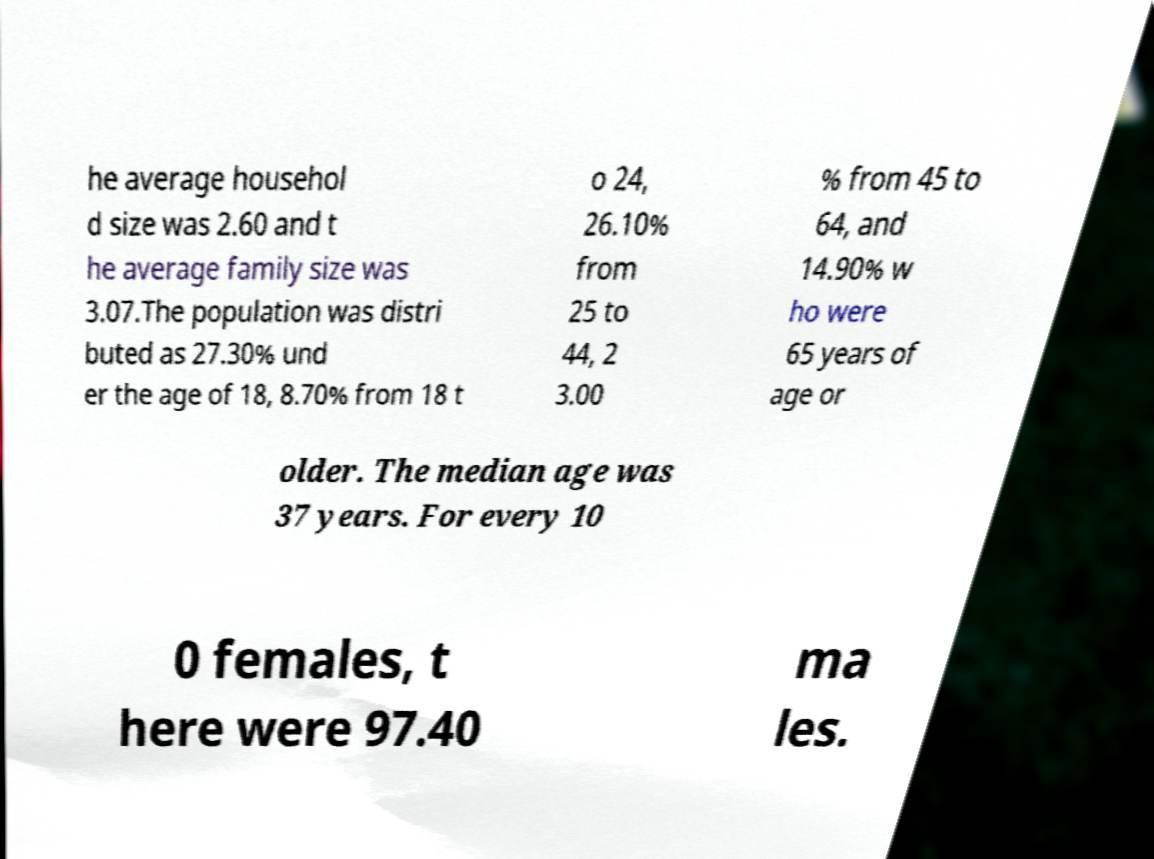Could you assist in decoding the text presented in this image and type it out clearly? he average househol d size was 2.60 and t he average family size was 3.07.The population was distri buted as 27.30% und er the age of 18, 8.70% from 18 t o 24, 26.10% from 25 to 44, 2 3.00 % from 45 to 64, and 14.90% w ho were 65 years of age or older. The median age was 37 years. For every 10 0 females, t here were 97.40 ma les. 